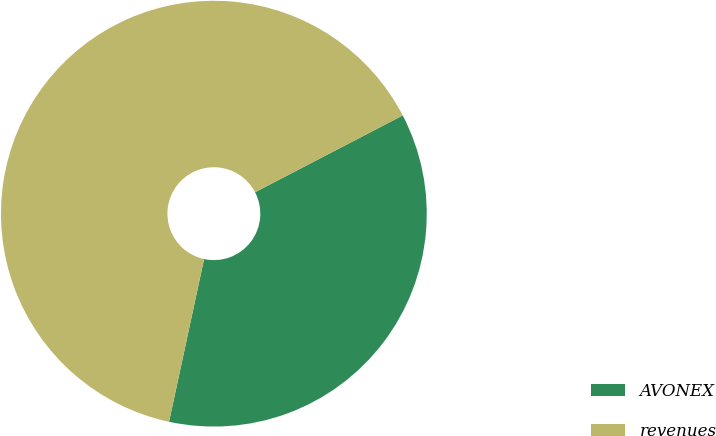Convert chart to OTSL. <chart><loc_0><loc_0><loc_500><loc_500><pie_chart><fcel>AVONEX<fcel>revenues<nl><fcel>36.01%<fcel>63.99%<nl></chart> 